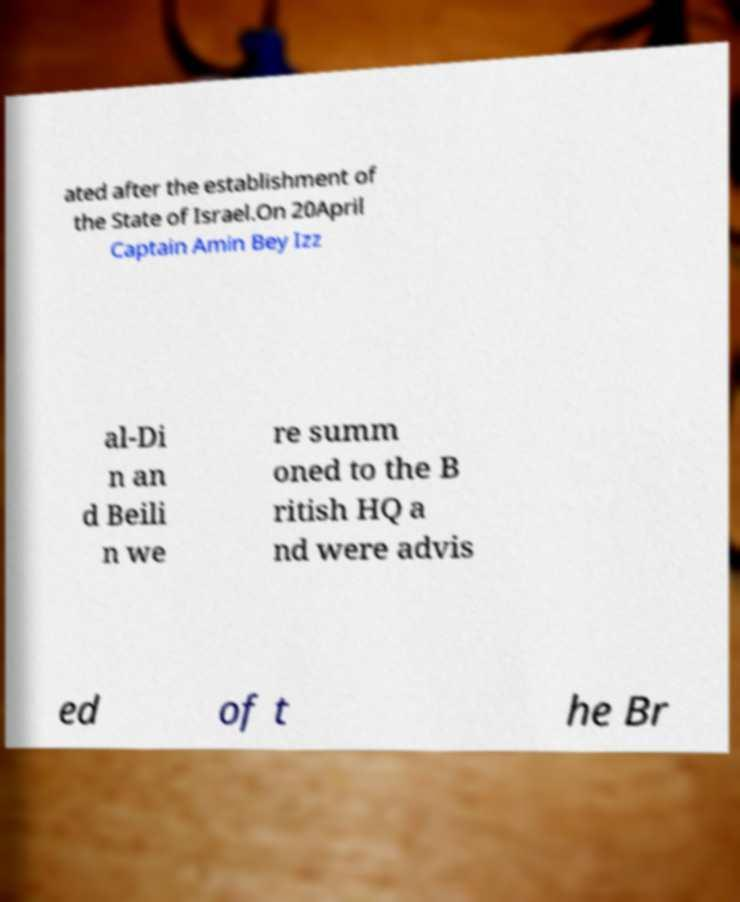Could you extract and type out the text from this image? ated after the establishment of the State of Israel.On 20April Captain Amin Bey Izz al-Di n an d Beili n we re summ oned to the B ritish HQ a nd were advis ed of t he Br 